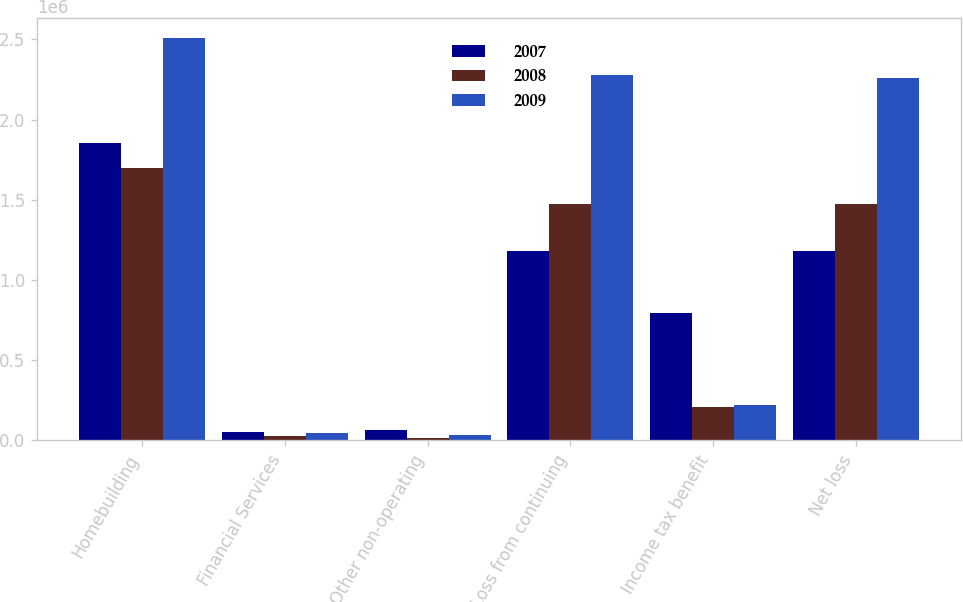Convert chart. <chart><loc_0><loc_0><loc_500><loc_500><stacked_bar_chart><ecel><fcel>Homebuilding<fcel>Financial Services<fcel>Other non-operating<fcel>Loss from continuing<fcel>Income tax benefit<fcel>Net loss<nl><fcel>2007<fcel>1.8533e+06<fcel>55038<fcel>66784<fcel>1.18257e+06<fcel>792552<fcel>1.18257e+06<nl><fcel>2008<fcel>1.69471e+06<fcel>28045<fcel>15933<fcel>1.47311e+06<fcel>209486<fcel>1.47311e+06<nl><fcel>2009<fcel>2.50949e+06<fcel>42980<fcel>30391<fcel>2.27442e+06<fcel>222486<fcel>2.25576e+06<nl></chart> 